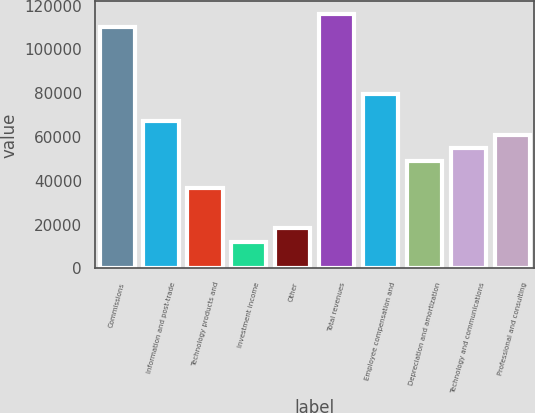Convert chart to OTSL. <chart><loc_0><loc_0><loc_500><loc_500><bar_chart><fcel>Commissions<fcel>Information and post-trade<fcel>Technology products and<fcel>Investment income<fcel>Other<fcel>Total revenues<fcel>Employee compensation and<fcel>Depreciation and amortization<fcel>Technology and communications<fcel>Professional and consulting<nl><fcel>110039<fcel>67246.2<fcel>36680<fcel>12227<fcel>18340.2<fcel>116152<fcel>79472.7<fcel>48906.5<fcel>55019.7<fcel>61133<nl></chart> 